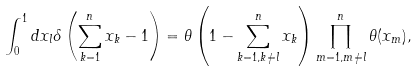Convert formula to latex. <formula><loc_0><loc_0><loc_500><loc_500>\int _ { 0 } ^ { 1 } d x _ { l } \delta \left ( \sum _ { k = 1 } ^ { n } x _ { k } - 1 \right ) = \theta \left ( 1 - \sum _ { k = 1 , k \neq l } ^ { n } x _ { k } \right ) \prod _ { m = 1 , m \neq l } ^ { n } \theta ( x _ { m } ) ,</formula> 